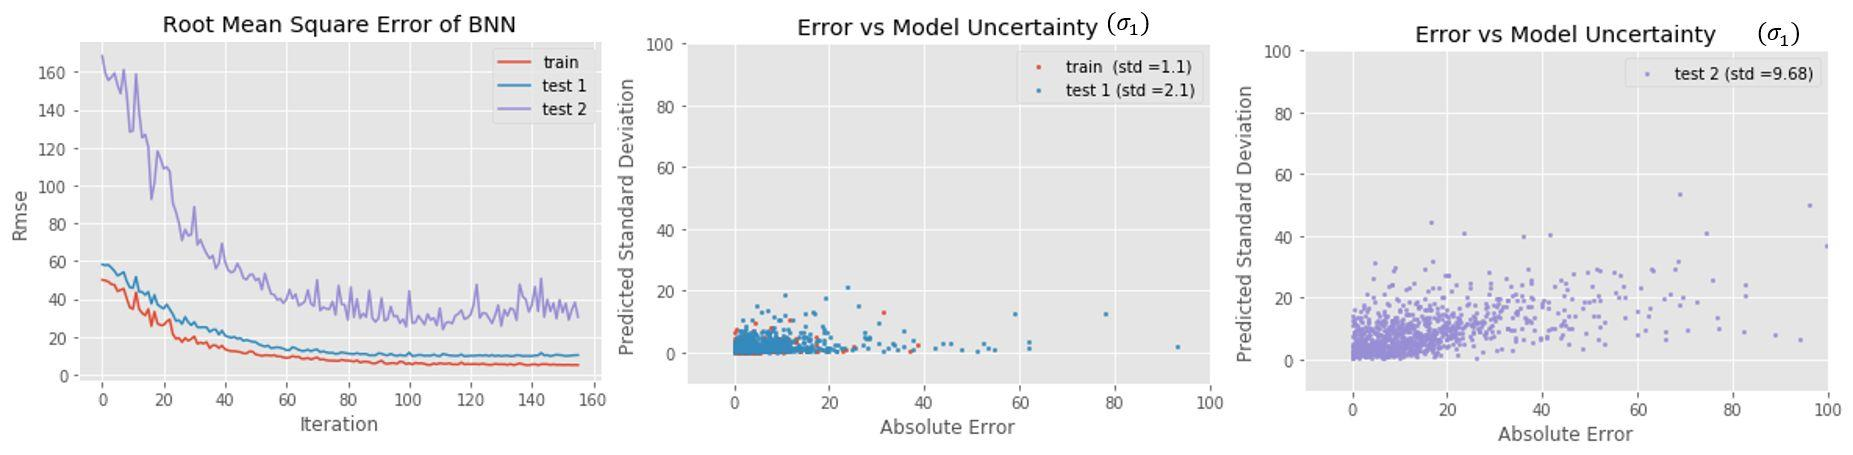How does the model uncertainty for 'test 2' compare to 'test 1' as shown in the figures? A. 'Test 2' has lower model uncertainty than 'test 1'. B. 'Test 2' has higher model uncertainty than 'test 1'. C. 'Test 2' and 'test 1' have the same level of model uncertainty. D. It's not possible to compare the model uncertainty between 'test 2' and 'test 1'. Upon evaluating the provided graphs, particularly focusing on the 'Error vs Model Uncertainty' plots for 'test 1' and 'test 2', one can discern that 'test 2' depicts a greater spread of data reflecting higher variability. This is quantitatively supported by examining the standard deviations; 'test 2' shows a standard deviation of 9.68, which is substantially larger than the 2.1 standard deviation for 'test 1'. This increased standard deviation for 'test 2' confirms that there is indeed a higher level of model uncertainty when compared with 'test 1'. Consequently, the accurate answer is B: 'Test 2' has higher model uncertainty than 'test 1'. 